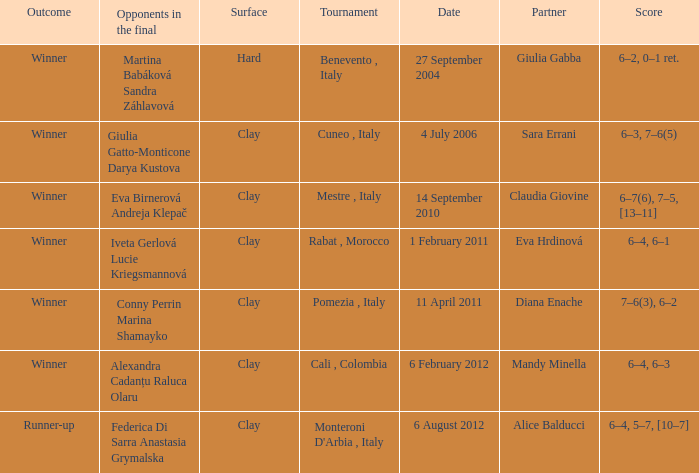Who played on a hard surface? Giulia Gabba. 